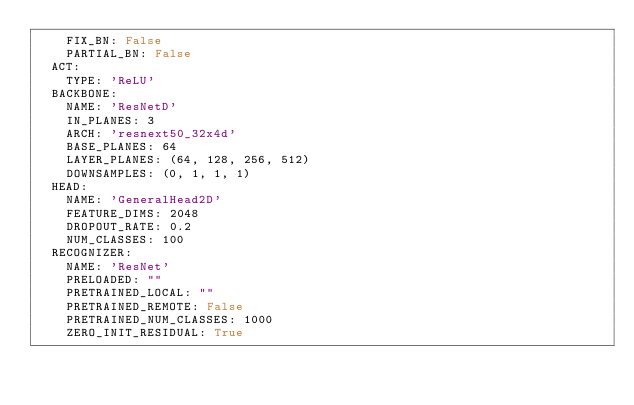Convert code to text. <code><loc_0><loc_0><loc_500><loc_500><_YAML_>    FIX_BN: False
    PARTIAL_BN: False
  ACT:
    TYPE: 'ReLU'
  BACKBONE:
    NAME: 'ResNetD'
    IN_PLANES: 3
    ARCH: 'resnext50_32x4d'
    BASE_PLANES: 64
    LAYER_PLANES: (64, 128, 256, 512)
    DOWNSAMPLES: (0, 1, 1, 1)
  HEAD:
    NAME: 'GeneralHead2D'
    FEATURE_DIMS: 2048
    DROPOUT_RATE: 0.2
    NUM_CLASSES: 100
  RECOGNIZER:
    NAME: 'ResNet'
    PRELOADED: ""
    PRETRAINED_LOCAL: ""
    PRETRAINED_REMOTE: False
    PRETRAINED_NUM_CLASSES: 1000
    ZERO_INIT_RESIDUAL: True</code> 